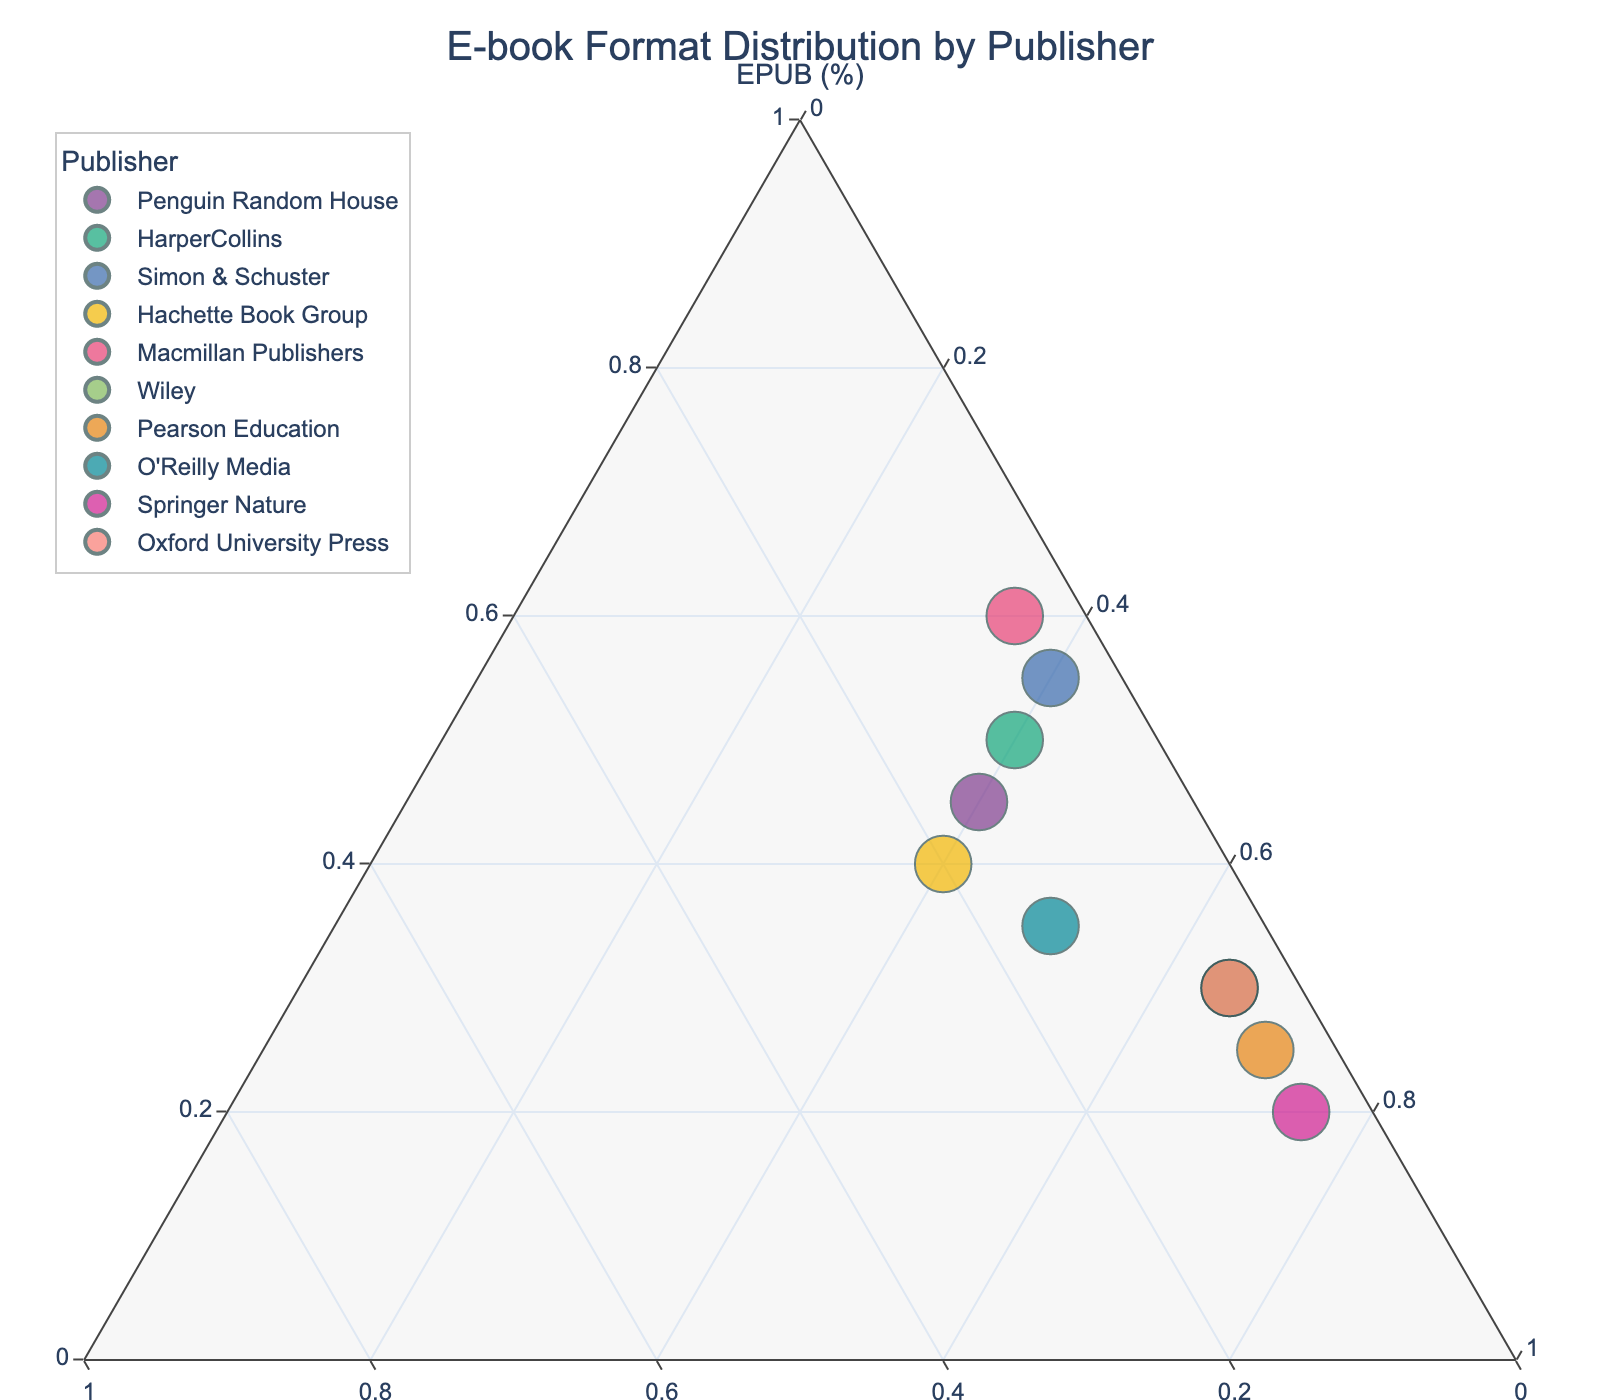What is the title of the plot? The title is a textual element typically displayed at the top of the plot. It provides a quick understanding of what the plot is portraying.
Answer: E-book Format Distribution by Publisher How many publishers are represented in the plot? Count the number of unique data points or different publishers in the ternary plot. Each publisher corresponds to a unique data point.
Answer: 10 Which publisher has the highest proportion of EPUB sales? Locate the data point that is nearest to the EPUB axis. This axis indicates the EPUB percentage, and the closer to this axis, the higher the proportion of EPUB sales.
Answer: Macmillan Publishers Are there any publishers with equal proportions of MOBI and EPUB sales? Check if any data points are equidistant from the EPUB and MOBI axes. This would indicate equal proportions of sales for both formats.
Answer: No What is the average proportion of PDF sales across all publishers? Sum the PDF proportions for all publishers and divide by the number of publishers to find the average. (0.40+0.40+0.40+0.40+0.35+0.65+0.70+0.50+0.75+0.65) / 10 = 4.2 / 10
Answer: 0.42 Which publishers have a higher proportion of MOBI sales than EPUB sales? Compare the positions of each data point relative to the MOBI and EPUB axes. The data points that are closer to the MOBI axis than the EPUB axis have higher MOBI sales.
Answer: Hachette Book Group Which publisher has the highest proportion of PDF sales? Locate the data point nearest to the PDF axis, which indicates the highest PDF sales proportion.
Answer: Springer Nature What is the combined proportion of EPUB and MOBI sales for O'Reilly Media? Add the proportions of EPUB and MOBI sales for O'Reilly Media and express it as a percentage. 0.35 + 0.15 = 0.50
Answer: 50% Which publisher has the least proportion of MOBI sales? Find the data point closest to the EPUB-PDF side of the ternary plot, as this would indicate the smallest MOBI proportion.
Answer: Simon & Schuster How do the proportions of EPUB and PDF sales for Wiley compare? Observe Wiley’s data point and compare its relative positions to the EPUB and PDF axes. The closer a data point is to an axis, the higher its proportion for that respective format.
Answer: Wiley has lower EPUB sales and higher PDF sales 